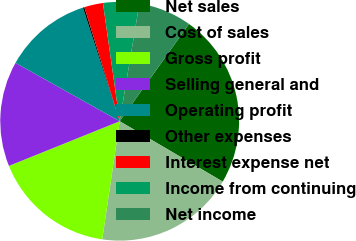Convert chart to OTSL. <chart><loc_0><loc_0><loc_500><loc_500><pie_chart><fcel>Net sales<fcel>Cost of sales<fcel>Gross profit<fcel>Selling general and<fcel>Operating profit<fcel>Other expenses<fcel>Interest expense net<fcel>Income from continuing<fcel>Net income<nl><fcel>23.58%<fcel>18.9%<fcel>16.57%<fcel>14.23%<fcel>11.89%<fcel>0.2%<fcel>2.54%<fcel>4.88%<fcel>7.22%<nl></chart> 